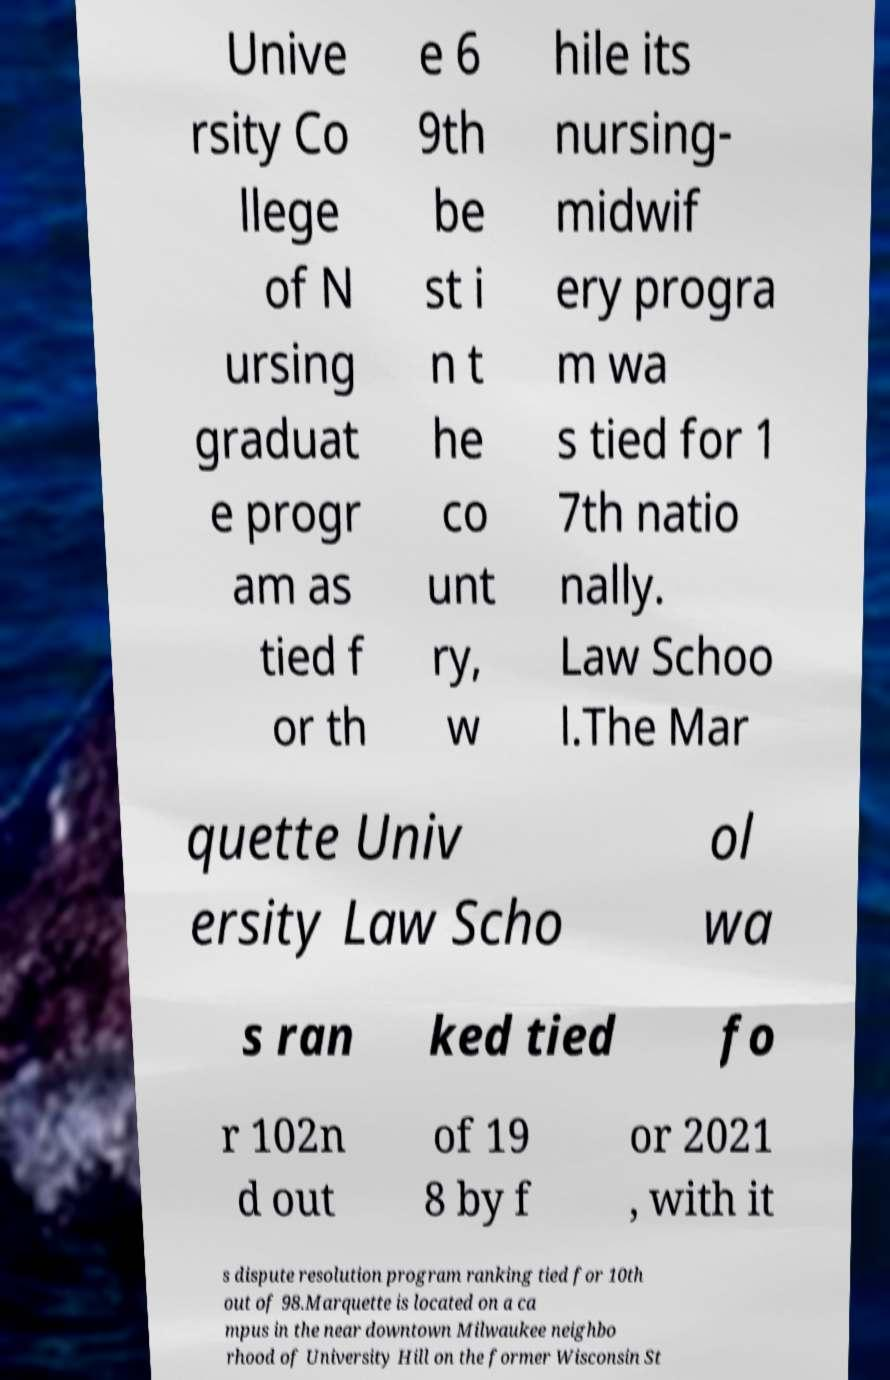Can you accurately transcribe the text from the provided image for me? Unive rsity Co llege of N ursing graduat e progr am as tied f or th e 6 9th be st i n t he co unt ry, w hile its nursing- midwif ery progra m wa s tied for 1 7th natio nally. Law Schoo l.The Mar quette Univ ersity Law Scho ol wa s ran ked tied fo r 102n d out of 19 8 by f or 2021 , with it s dispute resolution program ranking tied for 10th out of 98.Marquette is located on a ca mpus in the near downtown Milwaukee neighbo rhood of University Hill on the former Wisconsin St 